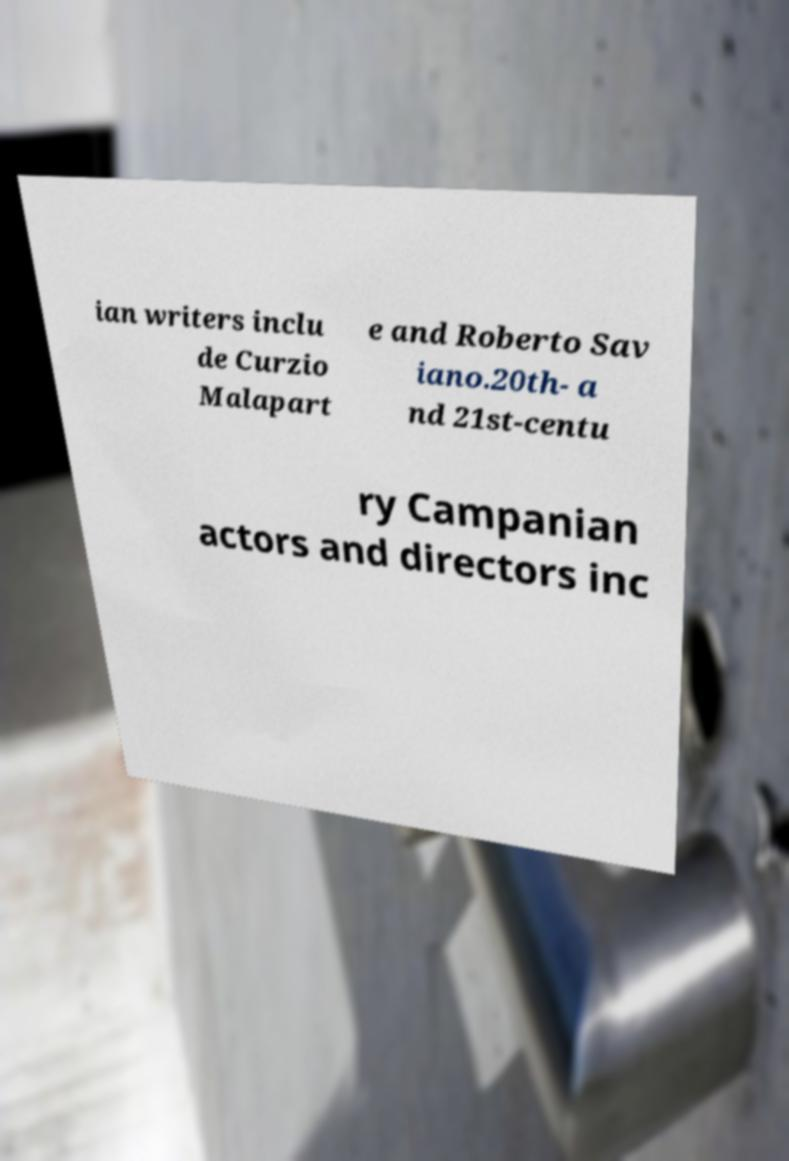Please identify and transcribe the text found in this image. ian writers inclu de Curzio Malapart e and Roberto Sav iano.20th- a nd 21st-centu ry Campanian actors and directors inc 